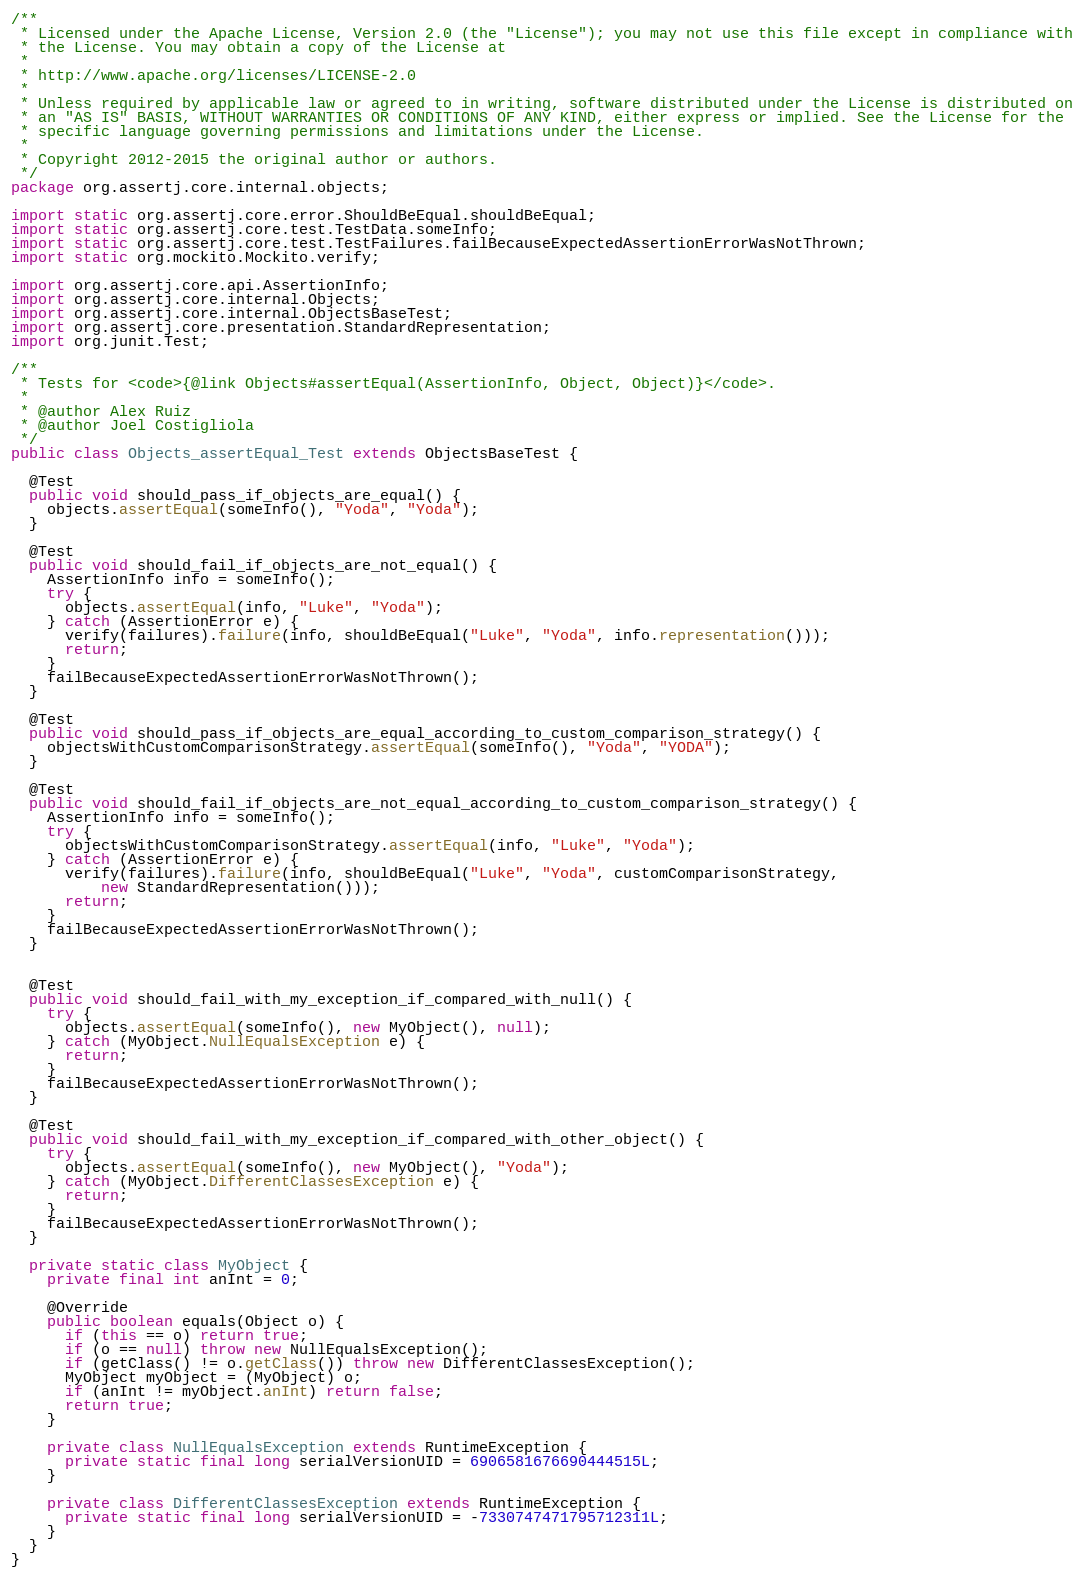<code> <loc_0><loc_0><loc_500><loc_500><_Java_>/**
 * Licensed under the Apache License, Version 2.0 (the "License"); you may not use this file except in compliance with
 * the License. You may obtain a copy of the License at
 *
 * http://www.apache.org/licenses/LICENSE-2.0
 *
 * Unless required by applicable law or agreed to in writing, software distributed under the License is distributed on
 * an "AS IS" BASIS, WITHOUT WARRANTIES OR CONDITIONS OF ANY KIND, either express or implied. See the License for the
 * specific language governing permissions and limitations under the License.
 *
 * Copyright 2012-2015 the original author or authors.
 */
package org.assertj.core.internal.objects;

import static org.assertj.core.error.ShouldBeEqual.shouldBeEqual;
import static org.assertj.core.test.TestData.someInfo;
import static org.assertj.core.test.TestFailures.failBecauseExpectedAssertionErrorWasNotThrown;
import static org.mockito.Mockito.verify;

import org.assertj.core.api.AssertionInfo;
import org.assertj.core.internal.Objects;
import org.assertj.core.internal.ObjectsBaseTest;
import org.assertj.core.presentation.StandardRepresentation;
import org.junit.Test;

/**
 * Tests for <code>{@link Objects#assertEqual(AssertionInfo, Object, Object)}</code>.
 * 
 * @author Alex Ruiz
 * @author Joel Costigliola
 */
public class Objects_assertEqual_Test extends ObjectsBaseTest {

  @Test
  public void should_pass_if_objects_are_equal() {
    objects.assertEqual(someInfo(), "Yoda", "Yoda");
  }

  @Test
  public void should_fail_if_objects_are_not_equal() {
    AssertionInfo info = someInfo();
    try {
      objects.assertEqual(info, "Luke", "Yoda");
    } catch (AssertionError e) {
      verify(failures).failure(info, shouldBeEqual("Luke", "Yoda", info.representation()));
      return;
    }
    failBecauseExpectedAssertionErrorWasNotThrown();
  }

  @Test
  public void should_pass_if_objects_are_equal_according_to_custom_comparison_strategy() {
    objectsWithCustomComparisonStrategy.assertEqual(someInfo(), "Yoda", "YODA");
  }

  @Test
  public void should_fail_if_objects_are_not_equal_according_to_custom_comparison_strategy() {
    AssertionInfo info = someInfo();
    try {
      objectsWithCustomComparisonStrategy.assertEqual(info, "Luke", "Yoda");
    } catch (AssertionError e) {
      verify(failures).failure(info, shouldBeEqual("Luke", "Yoda", customComparisonStrategy,
          new StandardRepresentation()));
      return;
    }
    failBecauseExpectedAssertionErrorWasNotThrown();
  }


  @Test
  public void should_fail_with_my_exception_if_compared_with_null() {
    try {
      objects.assertEqual(someInfo(), new MyObject(), null);
    } catch (MyObject.NullEqualsException e) {
      return;
    }
    failBecauseExpectedAssertionErrorWasNotThrown();
  }

  @Test
  public void should_fail_with_my_exception_if_compared_with_other_object() {
    try {
      objects.assertEqual(someInfo(), new MyObject(), "Yoda");
    } catch (MyObject.DifferentClassesException e) {
      return;
    }
    failBecauseExpectedAssertionErrorWasNotThrown();
  }

  private static class MyObject {
    private final int anInt = 0;

    @Override
    public boolean equals(Object o) {
      if (this == o) return true;
      if (o == null) throw new NullEqualsException();
      if (getClass() != o.getClass()) throw new DifferentClassesException();
      MyObject myObject = (MyObject) o;
      if (anInt != myObject.anInt) return false;
      return true;
    }

    private class NullEqualsException extends RuntimeException {
      private static final long serialVersionUID = 6906581676690444515L;
    }

    private class DifferentClassesException extends RuntimeException {
      private static final long serialVersionUID = -7330747471795712311L;
    }
  }
}
</code> 